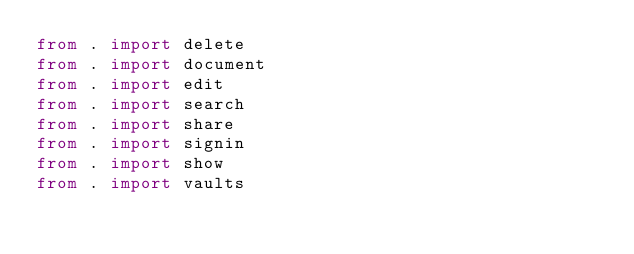<code> <loc_0><loc_0><loc_500><loc_500><_Python_>from . import delete
from . import document
from . import edit
from . import search
from . import share
from . import signin
from . import show
from . import vaults
</code> 